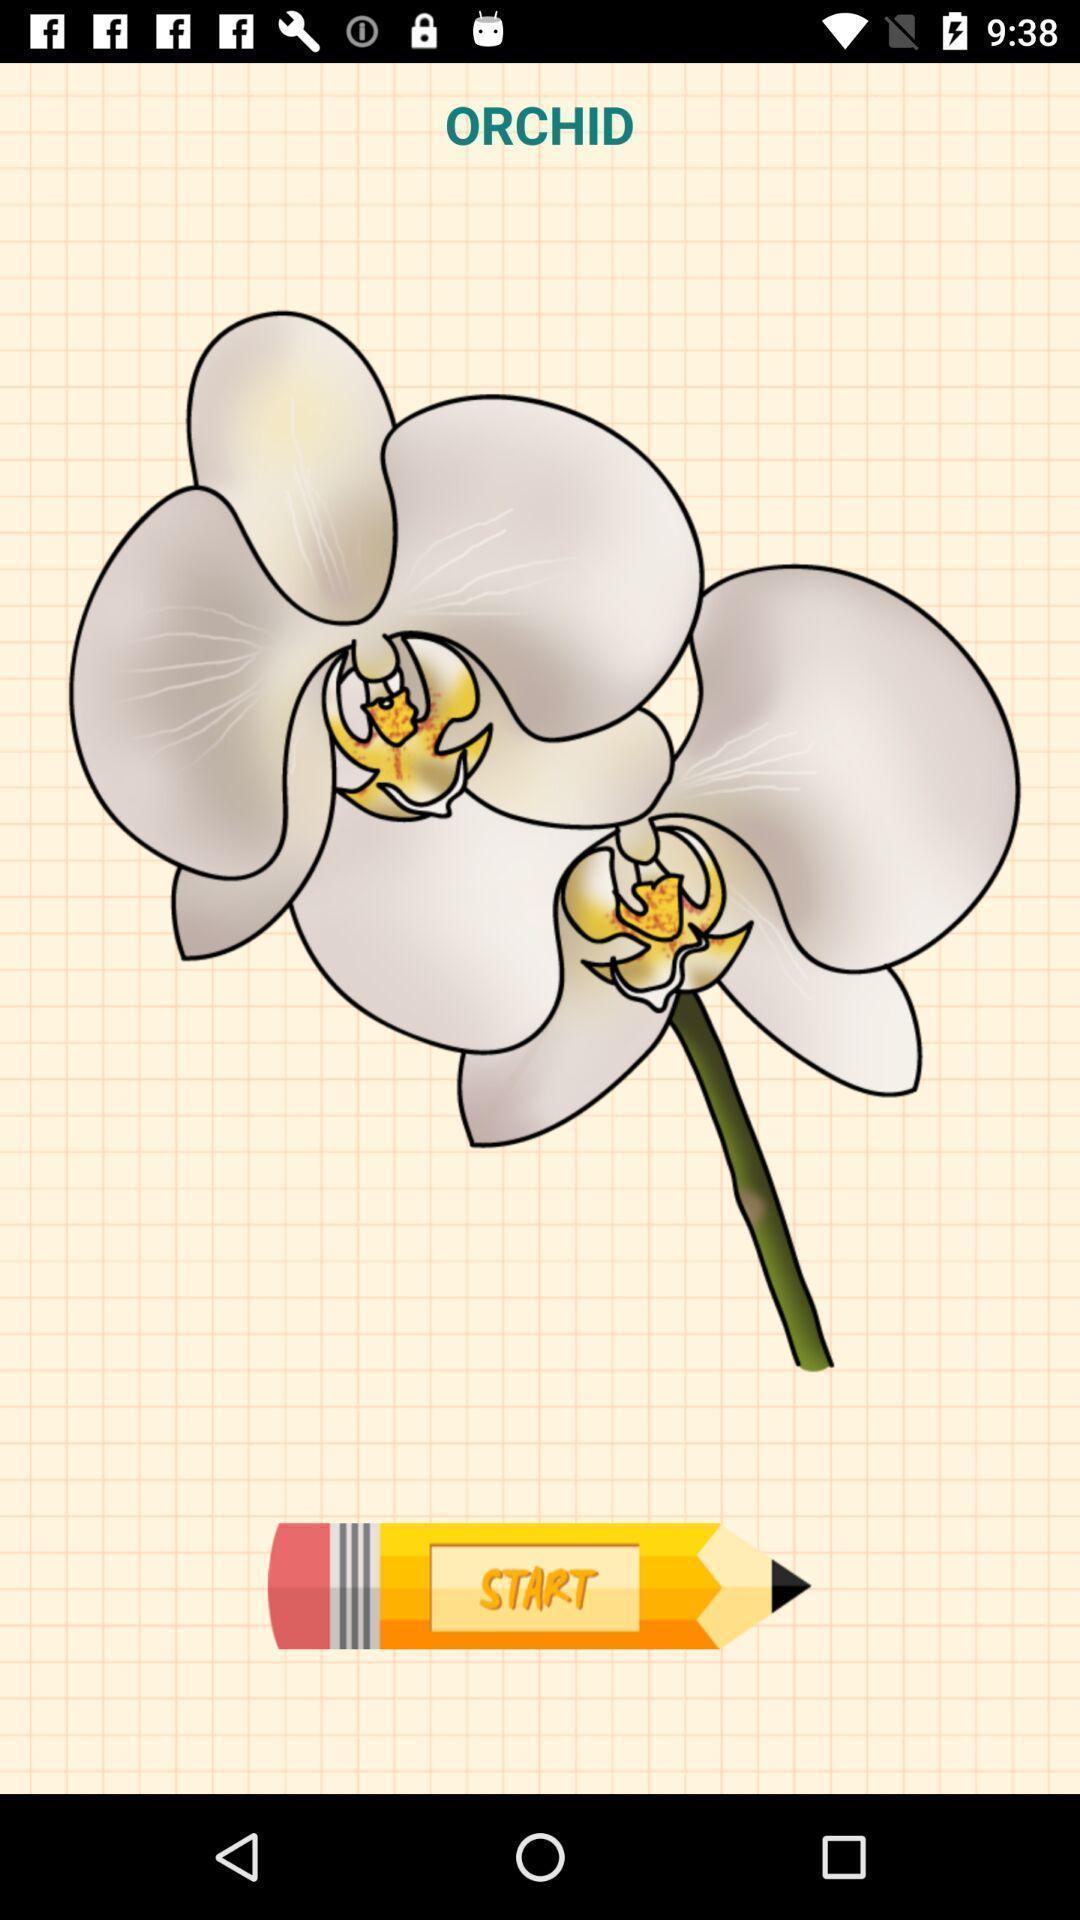Tell me what you see in this picture. Welcome page for an app. 